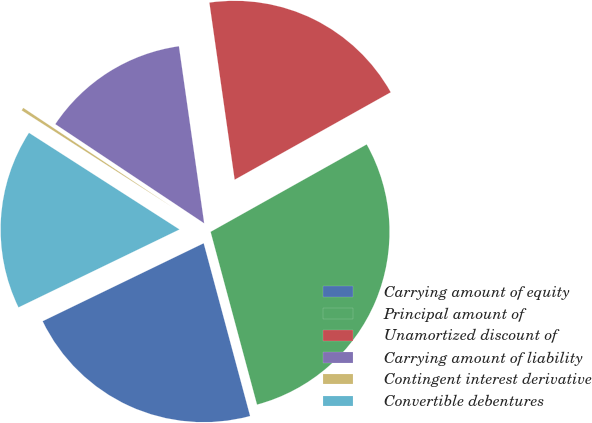Convert chart to OTSL. <chart><loc_0><loc_0><loc_500><loc_500><pie_chart><fcel>Carrying amount of equity<fcel>Principal amount of<fcel>Unamortized discount of<fcel>Carrying amount of liability<fcel>Contingent interest derivative<fcel>Convertible debentures<nl><fcel>22.0%<fcel>28.95%<fcel>19.13%<fcel>13.39%<fcel>0.27%<fcel>16.26%<nl></chart> 